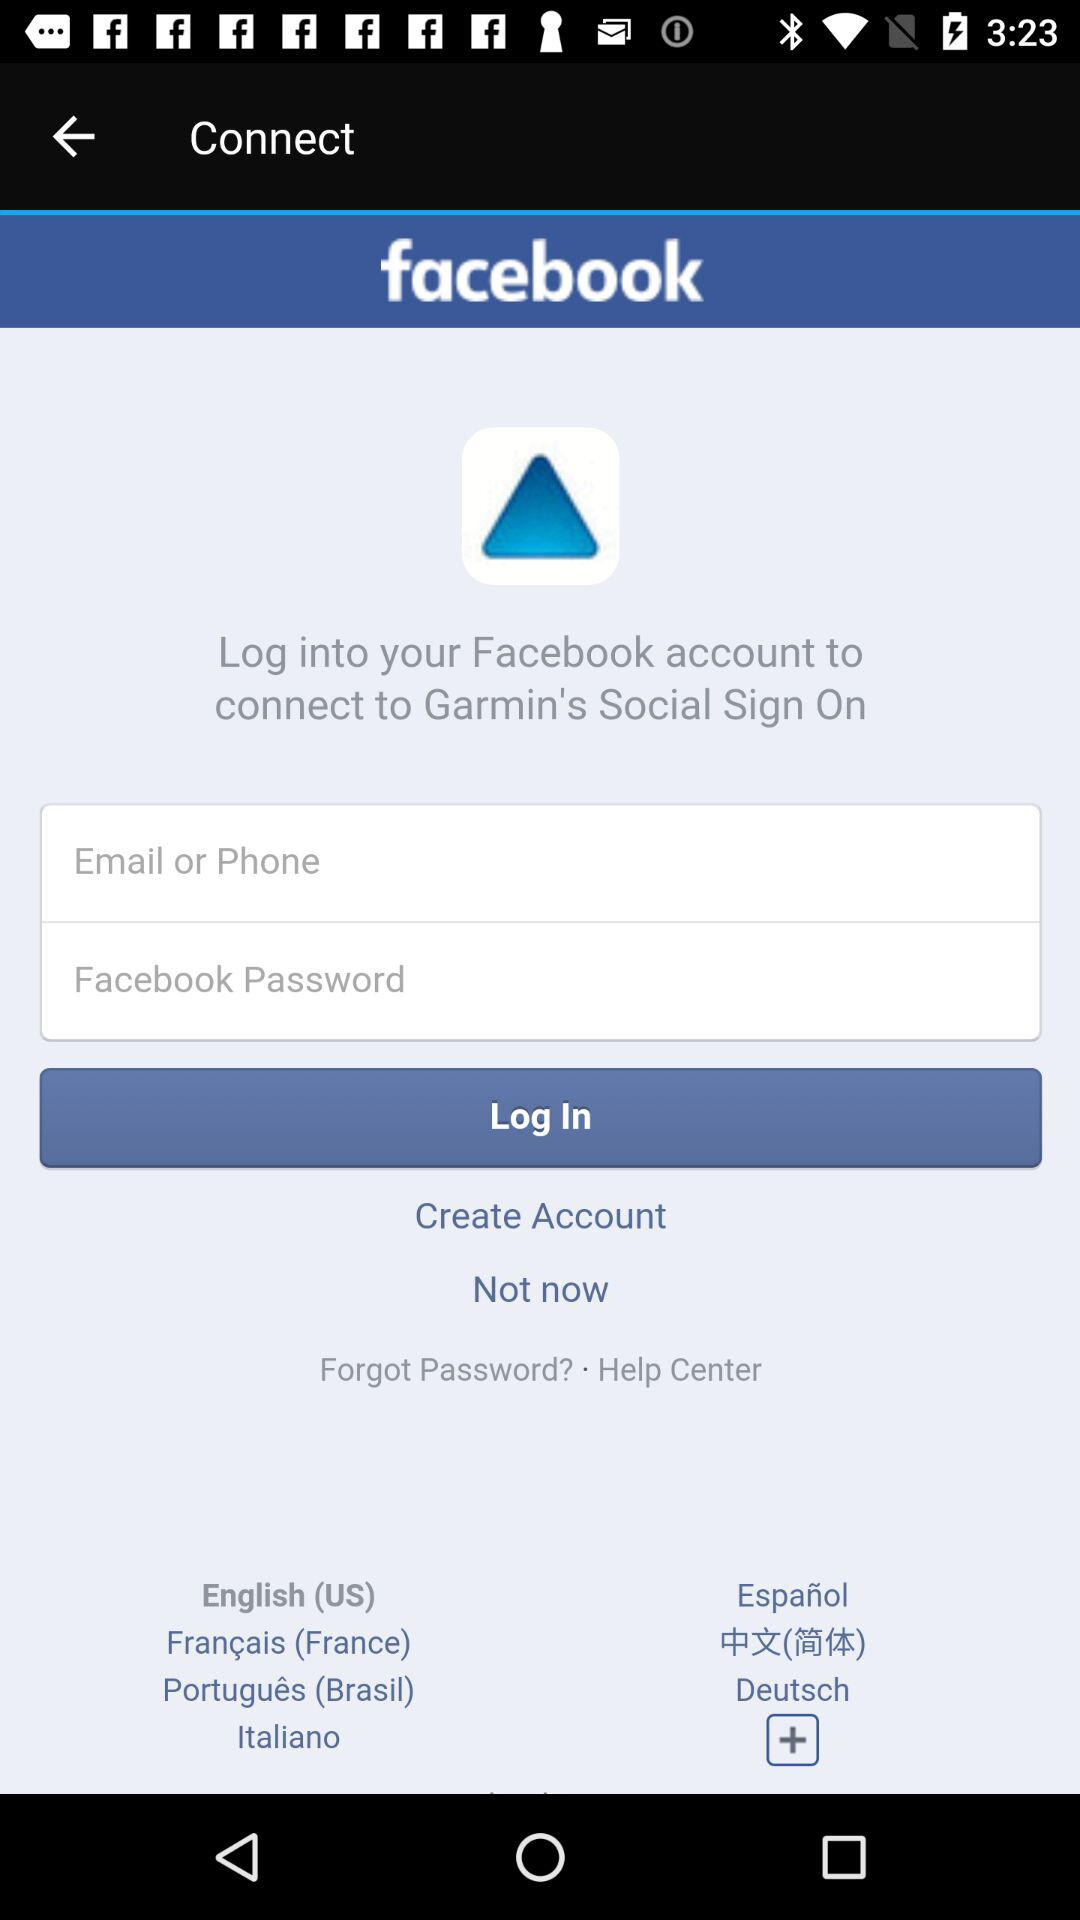What are the requirements to log in? The requirements to log in are "Email or Phone" and "Facebook Password". 